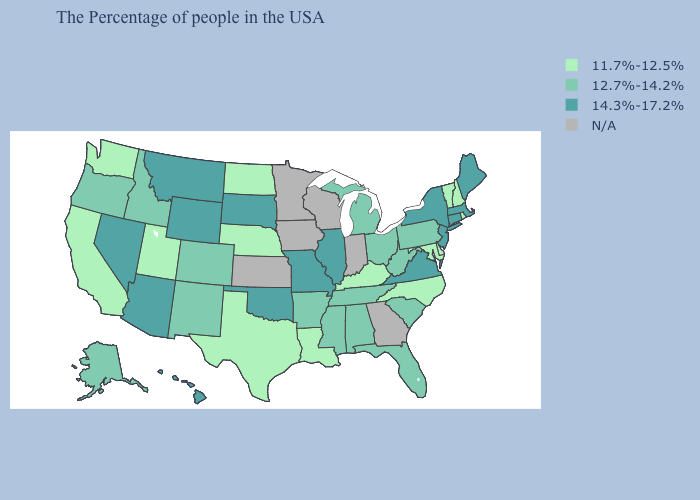Is the legend a continuous bar?
Keep it brief. No. Name the states that have a value in the range 14.3%-17.2%?
Concise answer only. Maine, Massachusetts, Connecticut, New York, New Jersey, Virginia, Illinois, Missouri, Oklahoma, South Dakota, Wyoming, Montana, Arizona, Nevada, Hawaii. What is the value of Oregon?
Give a very brief answer. 12.7%-14.2%. Among the states that border Delaware , which have the highest value?
Short answer required. New Jersey. What is the value of Oklahoma?
Give a very brief answer. 14.3%-17.2%. Name the states that have a value in the range 12.7%-14.2%?
Concise answer only. Pennsylvania, South Carolina, West Virginia, Ohio, Florida, Michigan, Alabama, Tennessee, Mississippi, Arkansas, Colorado, New Mexico, Idaho, Oregon, Alaska. Name the states that have a value in the range 14.3%-17.2%?
Concise answer only. Maine, Massachusetts, Connecticut, New York, New Jersey, Virginia, Illinois, Missouri, Oklahoma, South Dakota, Wyoming, Montana, Arizona, Nevada, Hawaii. What is the highest value in the USA?
Quick response, please. 14.3%-17.2%. Name the states that have a value in the range 14.3%-17.2%?
Answer briefly. Maine, Massachusetts, Connecticut, New York, New Jersey, Virginia, Illinois, Missouri, Oklahoma, South Dakota, Wyoming, Montana, Arizona, Nevada, Hawaii. What is the value of South Dakota?
Keep it brief. 14.3%-17.2%. Name the states that have a value in the range 14.3%-17.2%?
Answer briefly. Maine, Massachusetts, Connecticut, New York, New Jersey, Virginia, Illinois, Missouri, Oklahoma, South Dakota, Wyoming, Montana, Arizona, Nevada, Hawaii. Is the legend a continuous bar?
Concise answer only. No. Name the states that have a value in the range N/A?
Short answer required. Georgia, Indiana, Wisconsin, Minnesota, Iowa, Kansas. Name the states that have a value in the range 14.3%-17.2%?
Write a very short answer. Maine, Massachusetts, Connecticut, New York, New Jersey, Virginia, Illinois, Missouri, Oklahoma, South Dakota, Wyoming, Montana, Arizona, Nevada, Hawaii. Does the map have missing data?
Keep it brief. Yes. 